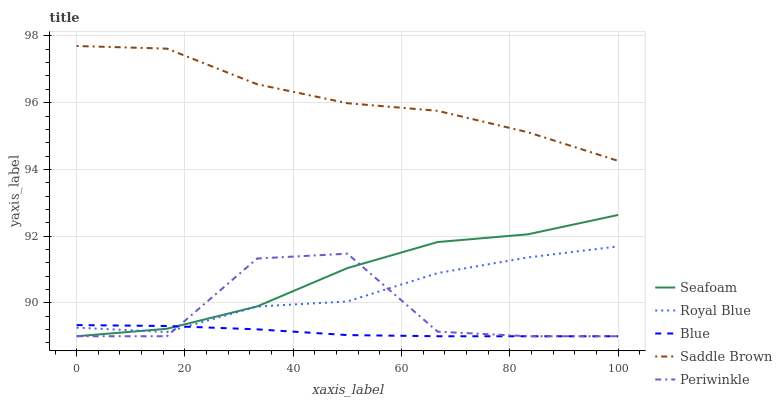Does Blue have the minimum area under the curve?
Answer yes or no. Yes. Does Saddle Brown have the maximum area under the curve?
Answer yes or no. Yes. Does Royal Blue have the minimum area under the curve?
Answer yes or no. No. Does Royal Blue have the maximum area under the curve?
Answer yes or no. No. Is Blue the smoothest?
Answer yes or no. Yes. Is Periwinkle the roughest?
Answer yes or no. Yes. Is Royal Blue the smoothest?
Answer yes or no. No. Is Royal Blue the roughest?
Answer yes or no. No. Does Royal Blue have the lowest value?
Answer yes or no. No. Does Royal Blue have the highest value?
Answer yes or no. No. Is Blue less than Saddle Brown?
Answer yes or no. Yes. Is Saddle Brown greater than Periwinkle?
Answer yes or no. Yes. Does Blue intersect Saddle Brown?
Answer yes or no. No. 